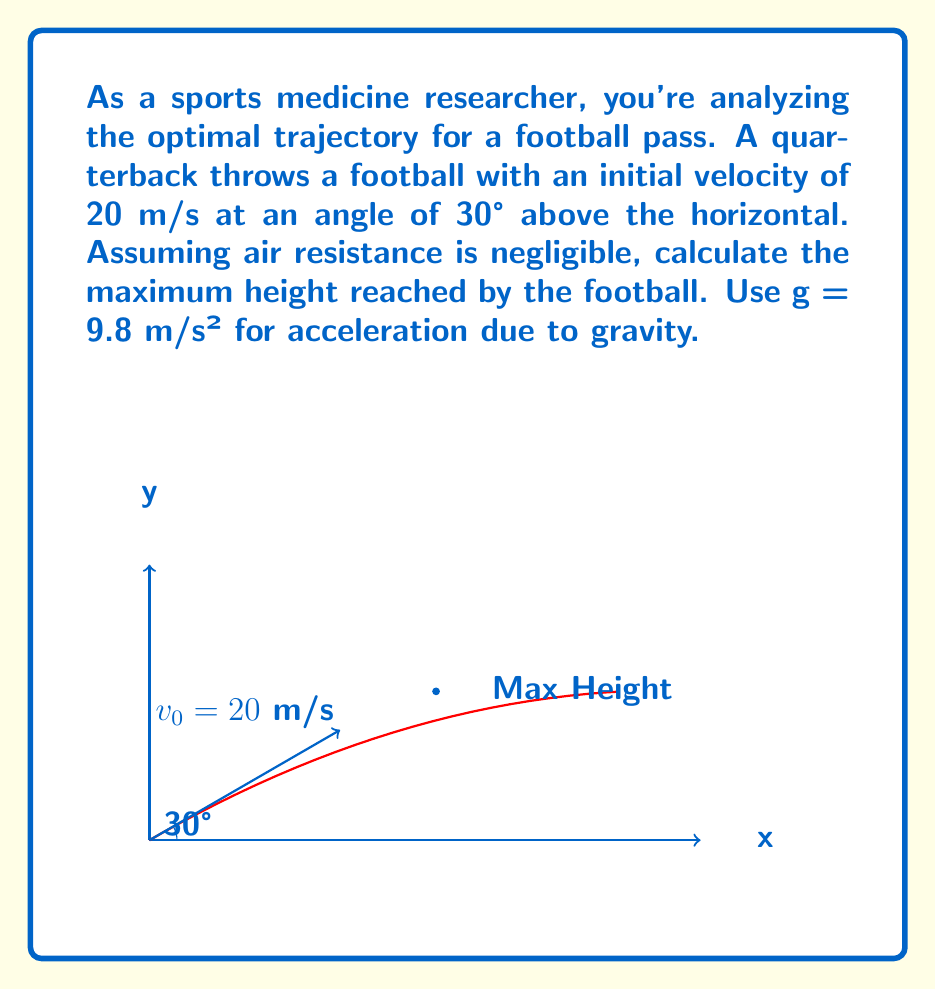Can you solve this math problem? Let's approach this step-by-step using the equations of motion for projectile motion:

1) First, we need to find the time it takes for the football to reach its maximum height. At this point, the vertical velocity is zero.

2) The vertical component of velocity is given by:
   $$v_y = v_0 \sin \theta - gt$$

3) At the highest point, $v_y = 0$, so:
   $$0 = v_0 \sin \theta - gt_{max}$$

4) Solving for $t_{max}$:
   $$t_{max} = \frac{v_0 \sin \theta}{g}$$

5) Substituting the given values:
   $$t_{max} = \frac{20 \sin 30°}{9.8} = \frac{20 \cdot 0.5}{9.8} = 1.02 \text{ seconds}$$

6) Now, we can use the equation for vertical displacement to find the maximum height:
   $$y = v_0 \sin \theta \cdot t - \frac{1}{2}gt^2$$

7) Substituting $t_{max}$ and the given values:
   $$y_{max} = 20 \sin 30° \cdot 1.02 - \frac{1}{2} \cdot 9.8 \cdot 1.02^2$$

8) Simplifying:
   $$y_{max} = 20 \cdot 0.5 \cdot 1.02 - \frac{1}{2} \cdot 9.8 \cdot 1.04$$
   $$y_{max} = 10.2 - 5.1 = 5.1 \text{ meters}$$

Therefore, the maximum height reached by the football is approximately 5.1 meters.
Answer: 5.1 meters 